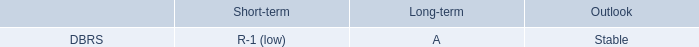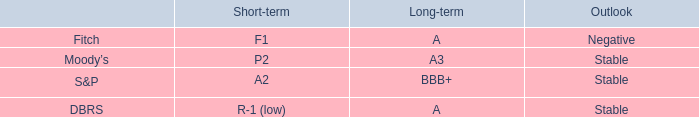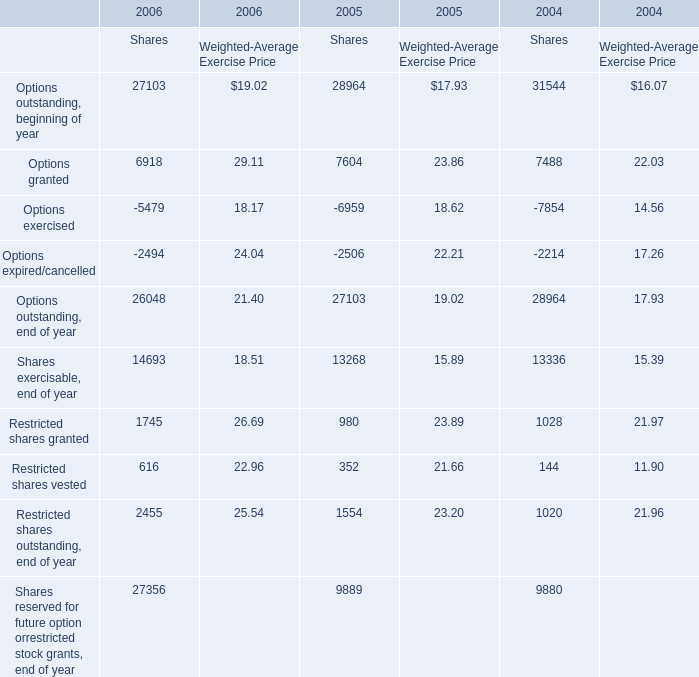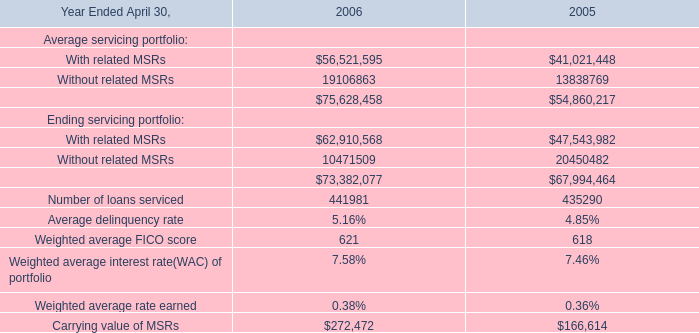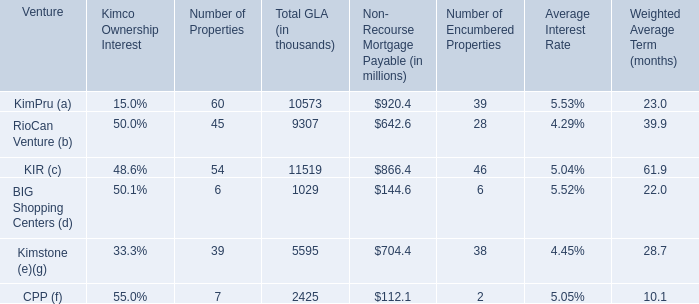What was the total amount of Sharesgreater than 10000 in 2006? 
Computations: ((27103 + 14693) + 27356)
Answer: 69152.0. 